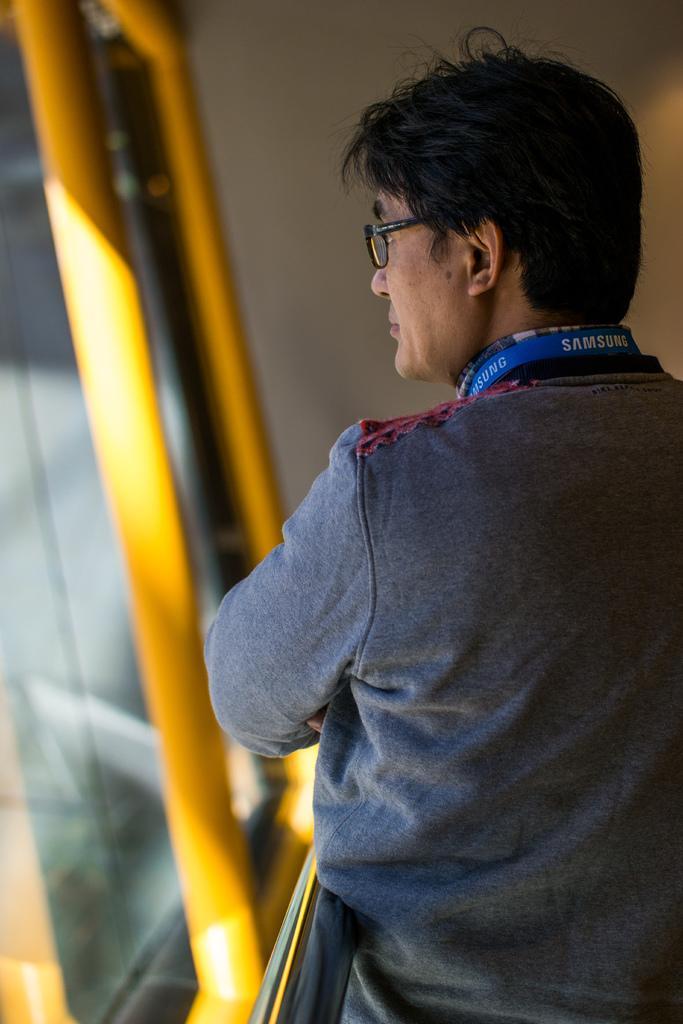Describe this image in one or two sentences. In the center of the image we can see one person standing and he is wearing glasses. On the left side of the image, we can see roads, which are in yellow color and glass. In the background there is a wall. 